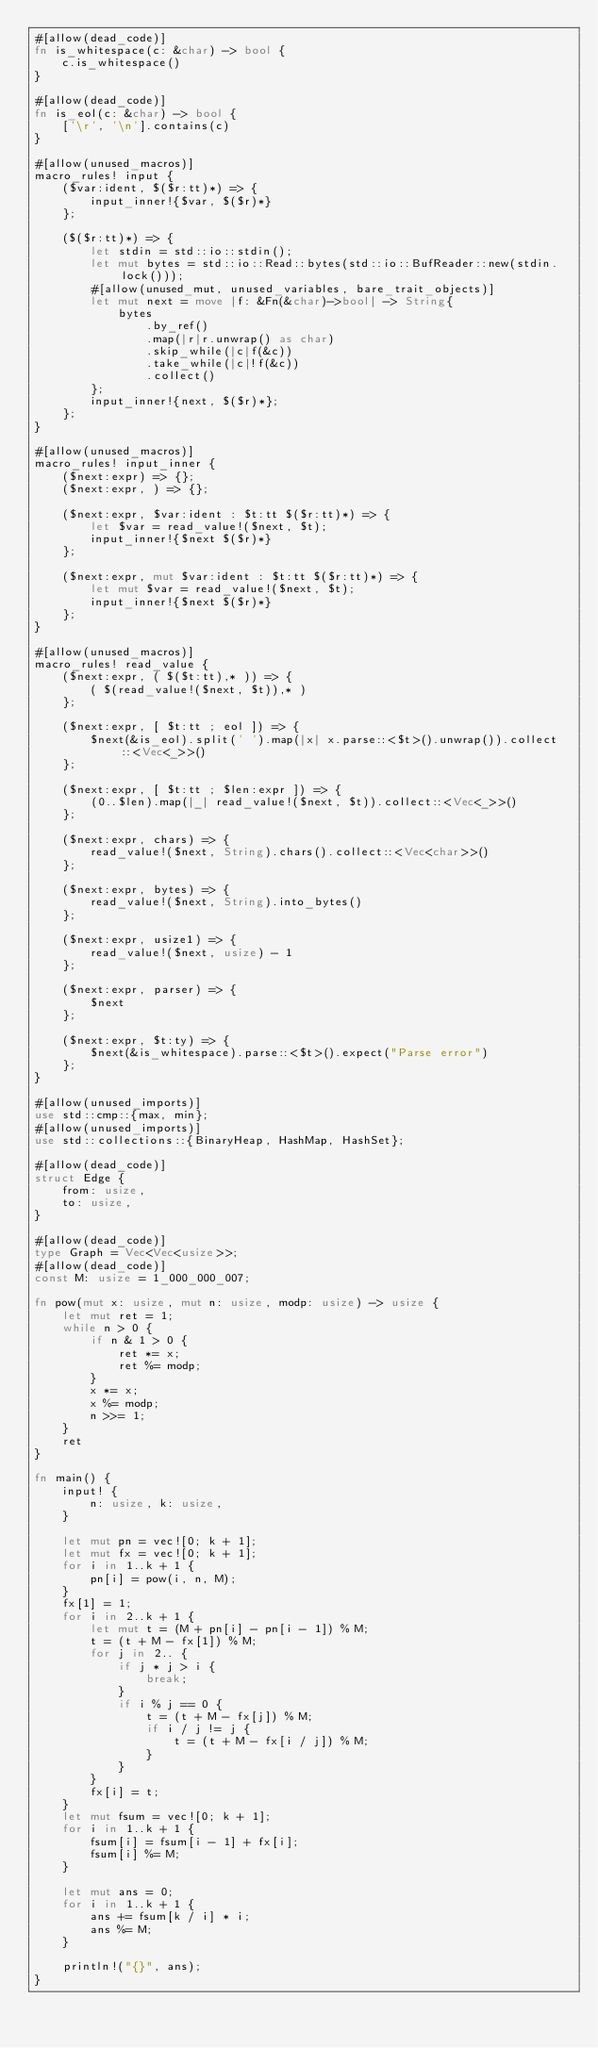<code> <loc_0><loc_0><loc_500><loc_500><_Rust_>#[allow(dead_code)]
fn is_whitespace(c: &char) -> bool {
    c.is_whitespace()
}

#[allow(dead_code)]
fn is_eol(c: &char) -> bool {
    ['\r', '\n'].contains(c)
}

#[allow(unused_macros)]
macro_rules! input {
    ($var:ident, $($r:tt)*) => {
        input_inner!{$var, $($r)*}
    };

    ($($r:tt)*) => {
        let stdin = std::io::stdin();
        let mut bytes = std::io::Read::bytes(std::io::BufReader::new(stdin.lock()));
        #[allow(unused_mut, unused_variables, bare_trait_objects)]
        let mut next = move |f: &Fn(&char)->bool| -> String{
            bytes
                .by_ref()
                .map(|r|r.unwrap() as char)
                .skip_while(|c|f(&c))
                .take_while(|c|!f(&c))
                .collect()
        };
        input_inner!{next, $($r)*};
    };
}

#[allow(unused_macros)]
macro_rules! input_inner {
    ($next:expr) => {};
    ($next:expr, ) => {};

    ($next:expr, $var:ident : $t:tt $($r:tt)*) => {
        let $var = read_value!($next, $t);
        input_inner!{$next $($r)*}
    };

    ($next:expr, mut $var:ident : $t:tt $($r:tt)*) => {
        let mut $var = read_value!($next, $t);
        input_inner!{$next $($r)*}
    };
}

#[allow(unused_macros)]
macro_rules! read_value {
    ($next:expr, ( $($t:tt),* )) => {
        ( $(read_value!($next, $t)),* )
    };

    ($next:expr, [ $t:tt ; eol ]) => {
        $next(&is_eol).split(' ').map(|x| x.parse::<$t>().unwrap()).collect::<Vec<_>>()
    };

    ($next:expr, [ $t:tt ; $len:expr ]) => {
        (0..$len).map(|_| read_value!($next, $t)).collect::<Vec<_>>()
    };

    ($next:expr, chars) => {
        read_value!($next, String).chars().collect::<Vec<char>>()
    };

    ($next:expr, bytes) => {
        read_value!($next, String).into_bytes()
    };

    ($next:expr, usize1) => {
        read_value!($next, usize) - 1
    };

    ($next:expr, parser) => {
        $next
    };

    ($next:expr, $t:ty) => {
        $next(&is_whitespace).parse::<$t>().expect("Parse error")
    };
}

#[allow(unused_imports)]
use std::cmp::{max, min};
#[allow(unused_imports)]
use std::collections::{BinaryHeap, HashMap, HashSet};

#[allow(dead_code)]
struct Edge {
    from: usize,
    to: usize,
}

#[allow(dead_code)]
type Graph = Vec<Vec<usize>>;
#[allow(dead_code)]
const M: usize = 1_000_000_007;

fn pow(mut x: usize, mut n: usize, modp: usize) -> usize {
    let mut ret = 1;
    while n > 0 {
        if n & 1 > 0 {
            ret *= x;
            ret %= modp;
        }
        x *= x;
        x %= modp;
        n >>= 1;
    }
    ret
}

fn main() {
    input! {
        n: usize, k: usize,
    }

    let mut pn = vec![0; k + 1];
    let mut fx = vec![0; k + 1];
    for i in 1..k + 1 {
        pn[i] = pow(i, n, M);
    }
    fx[1] = 1;
    for i in 2..k + 1 {
        let mut t = (M + pn[i] - pn[i - 1]) % M;
        t = (t + M - fx[1]) % M;
        for j in 2.. {
            if j * j > i {
                break;
            }
            if i % j == 0 {
                t = (t + M - fx[j]) % M;
                if i / j != j {
                    t = (t + M - fx[i / j]) % M;
                }
            }
        }
        fx[i] = t;
    }
    let mut fsum = vec![0; k + 1];
    for i in 1..k + 1 {
        fsum[i] = fsum[i - 1] + fx[i];
        fsum[i] %= M;
    }

    let mut ans = 0;
    for i in 1..k + 1 {
        ans += fsum[k / i] * i;
        ans %= M;
    }

    println!("{}", ans);
}
</code> 